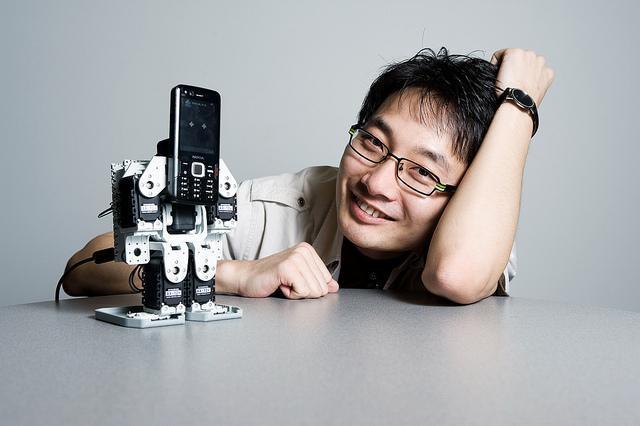How many cat does he have?
Give a very brief answer. 0. 